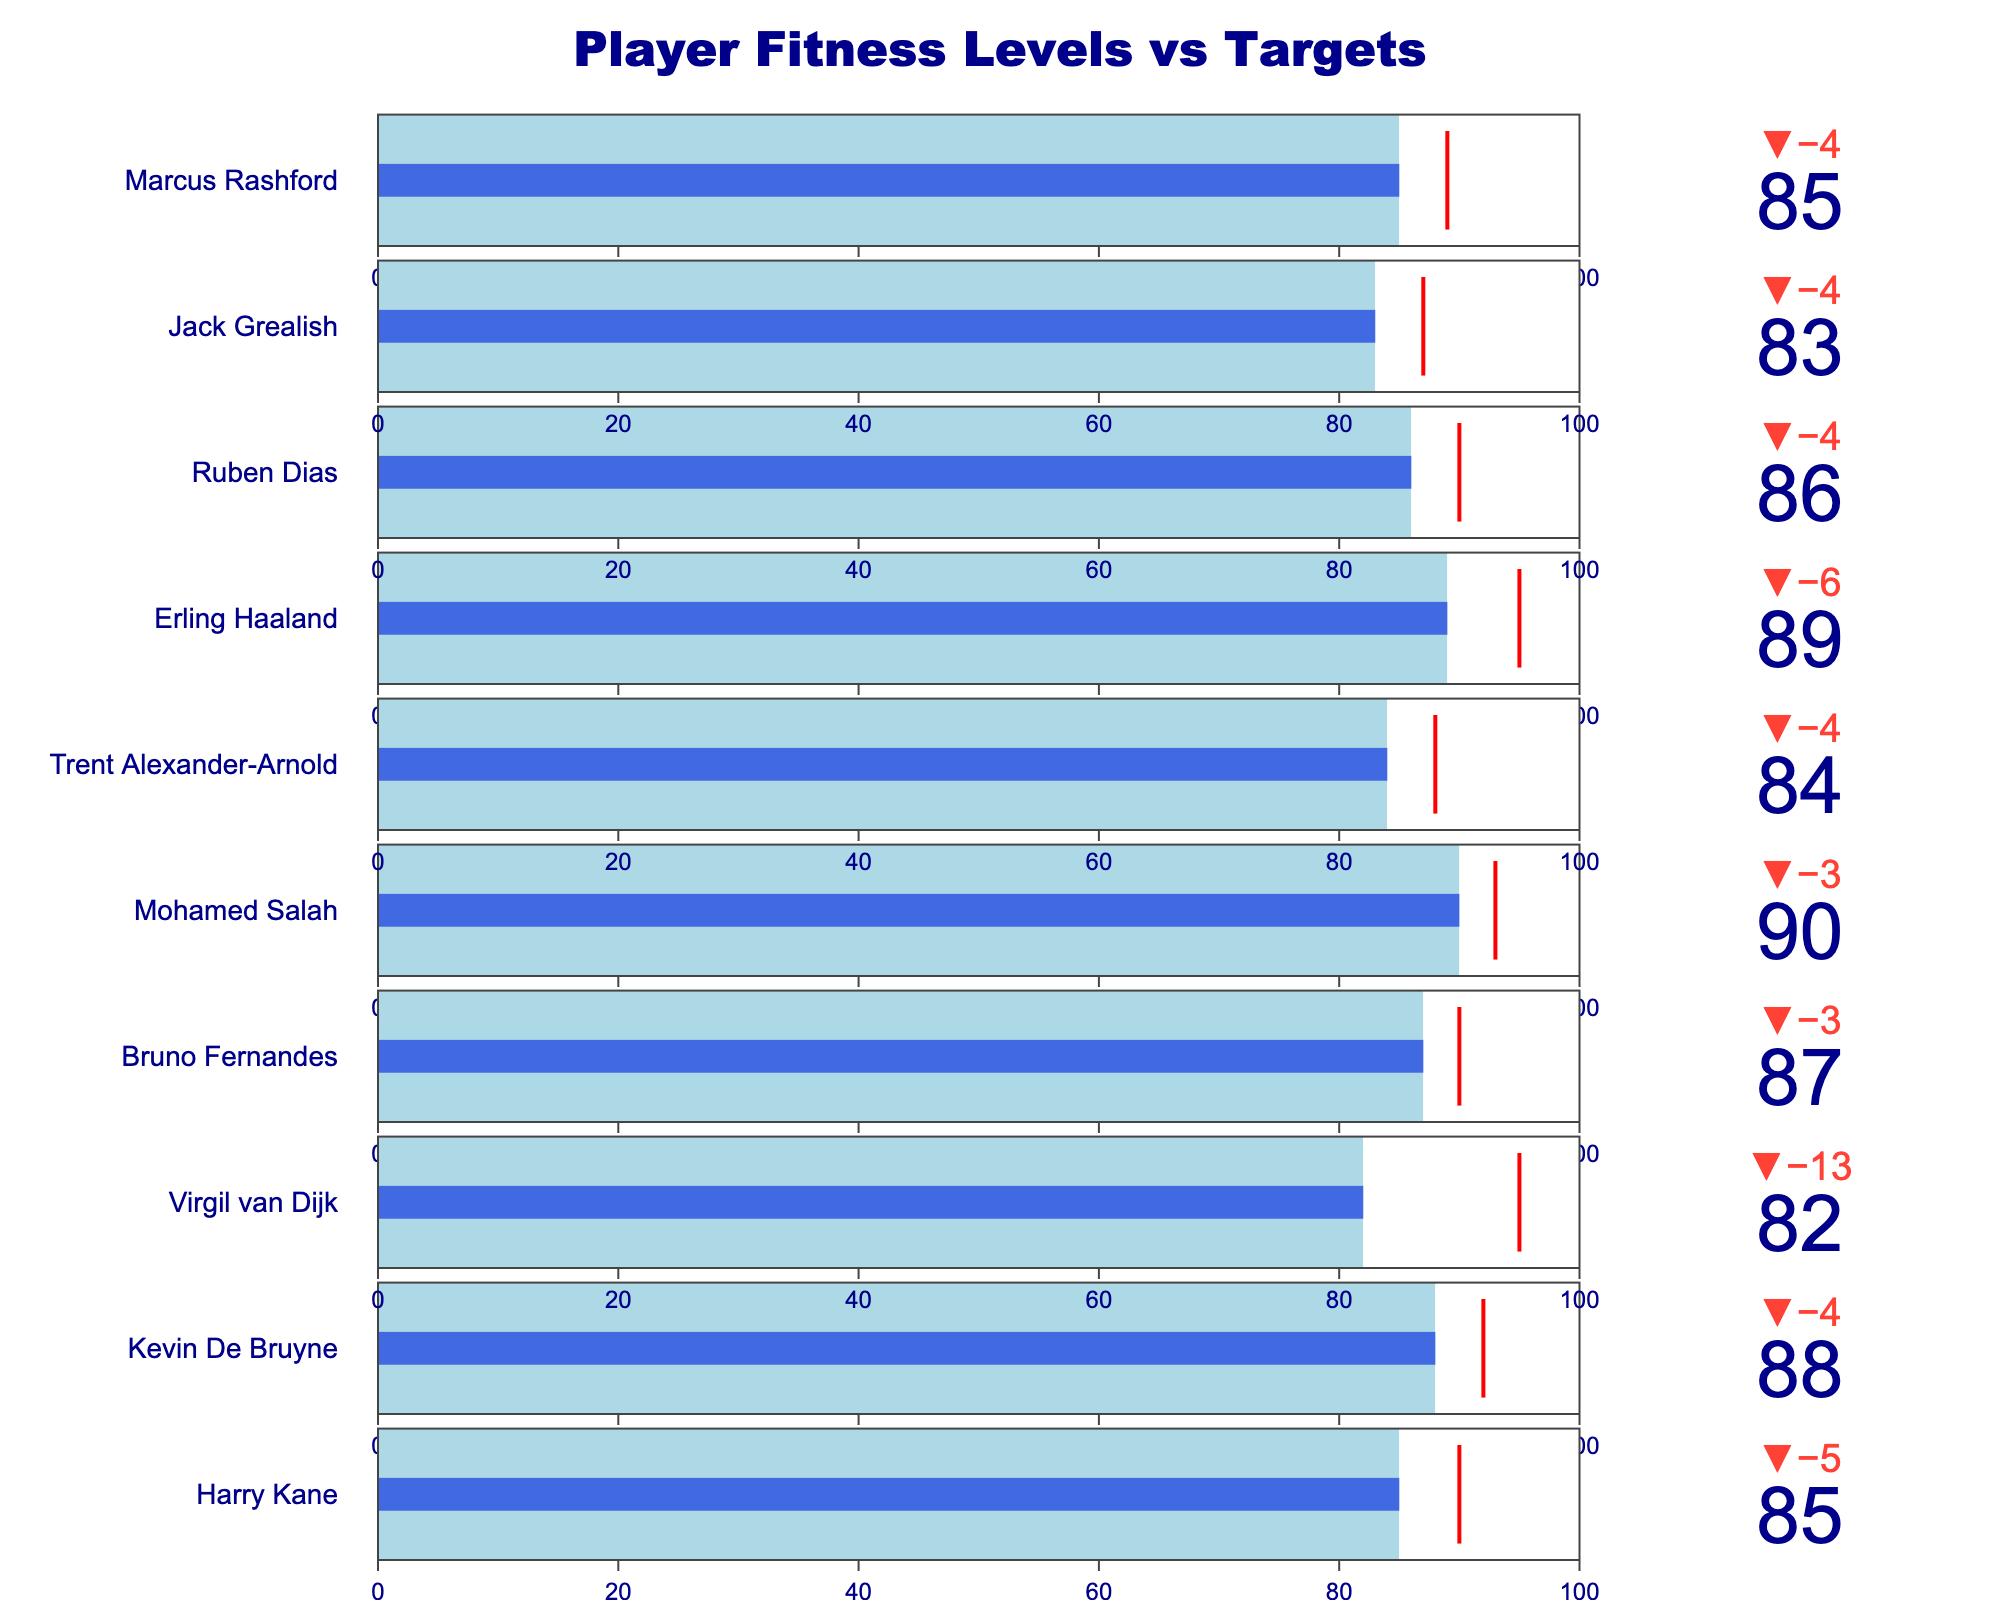How many players have an actual fitness level higher than 85? There are three players with an actual fitness level higher than 85: Kevin De Bruyne (88), Mohamed Salah (90), and Erling Haaland (89).
Answer: 3 Which player has the biggest gap between their actual fitness and their target fitness? The player with the biggest gap between actual fitness and target fitness is Virgil van Dijk. His actual fitness is 82, and his target fitness is 95, making the difference 13.
Answer: Virgil van Dijk Which player has the highest actual fitness level? By looking at the values, Mohamed Salah has the highest actual fitness level with a value of 90.
Answer: Mohamed Salah Who meets their target fitness level but falls short of their maximum fitness level? No player meets their target fitness level exactly as no bars reach the red threshold lines but stay below the maximum fitness level.
Answer: None For which player is their actual fitness closest to their target fitness? Harry Kane's actual fitness (85) is closest to his target fitness (90), with a difference of 5.
Answer: Harry Kane What is the average target fitness level across all the players? Adding up all target fitness levels: 90 + 92 + 95 + 90 + 93 + 88 + 95 + 90 + 87 + 89 = 909. Dividing by the number of players (10): 909 / 10 = 90.9.
Answer: 90.9 Who has the smallest difference between actual fitness and maximum fitness? Several players, including Harry Kane and Kevin De Bruyne, have similar differences, but Mohamed Salah has the smallest difference, with 10 (90 actual, 100 maximum).
Answer: Mohamed Salah Which three players have the lowest actual fitness levels? The three players with the lowest actual fitness levels are Virgil van Dijk (82), Jack Grealish (83), and Trent Alexander-Arnold (84).
Answer: Virgil van Dijk, Jack Grealish, Trent Alexander-Arnold How many players have an actual fitness level higher than or equal to 85 but lower than 90? There are five players with actual fitness levels in this range: Harry Kane (85), Bruno Fernandes (87), Trent Alexander-Arnold (84), Ruben Dias (86), and Marcus Rashford (85).
Answer: 5 